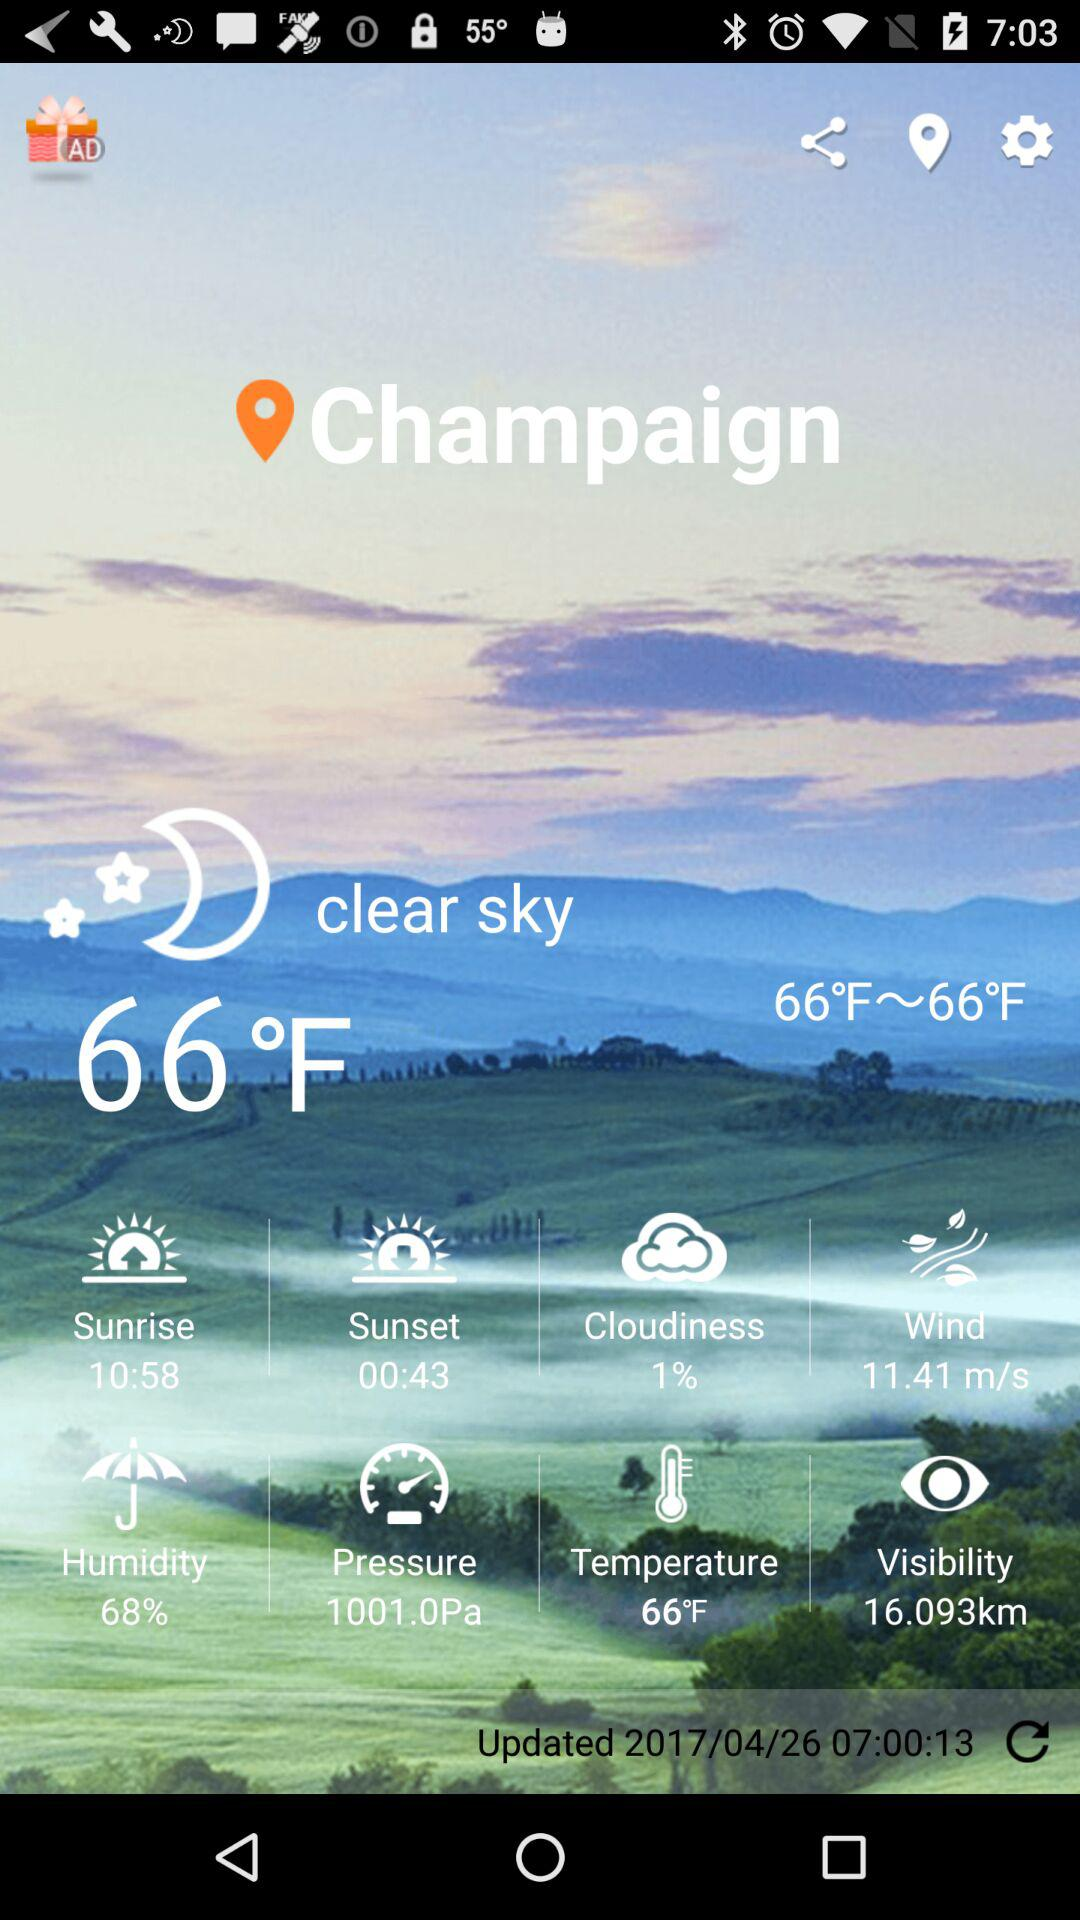How's the weather today? The weather is "clear sky". 